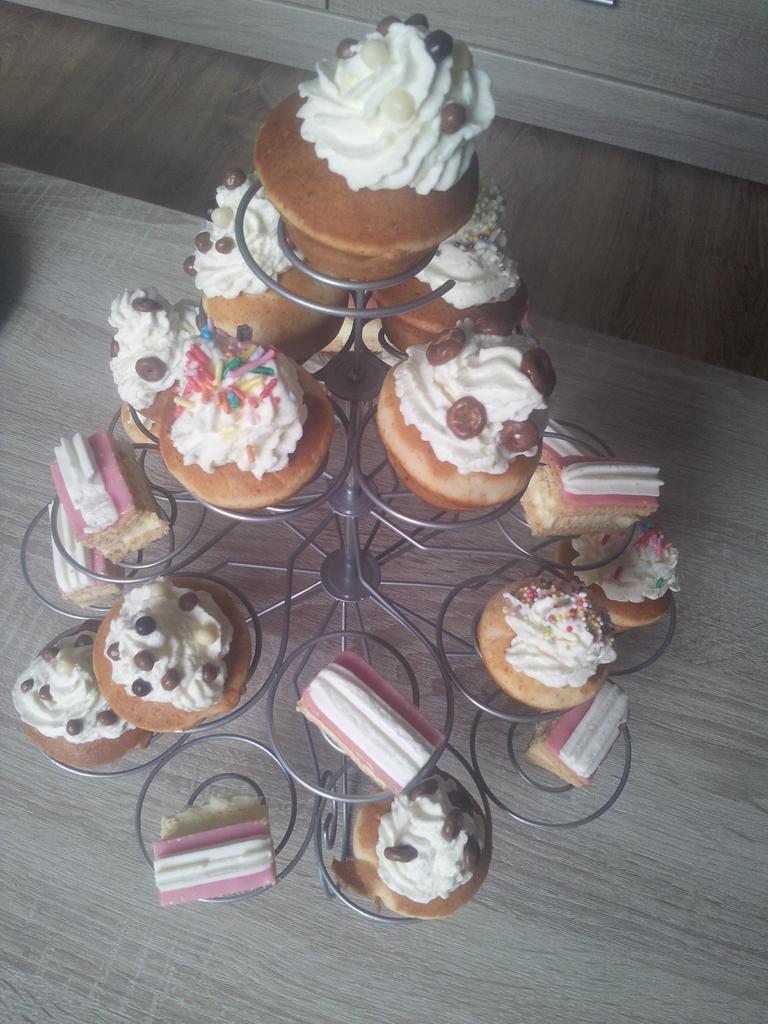Could you give a brief overview of what you see in this image? This is a zoomed in picture. In the center there is a metal stand on which we can see the cupcakes are placed and the stand is placed on the ground. In the background there is an object. 